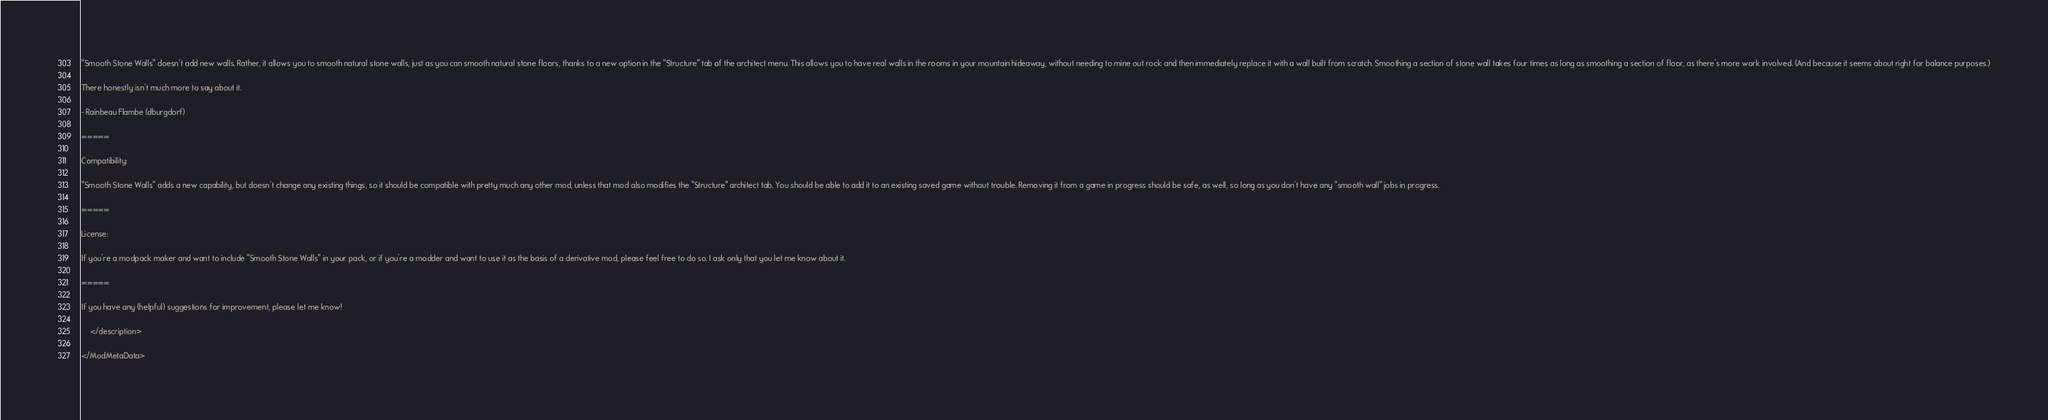Convert code to text. <code><loc_0><loc_0><loc_500><loc_500><_XML_>
"Smooth Stone Walls" doesn't add new walls. Rather, it allows you to smooth natural stone walls, just as you can smooth natural stone floors, thanks to a new option in the "Structure" tab of the architect menu. This allows you to have real walls in the rooms in your mountain hideaway, without needing to mine out rock and then immediately replace it with a wall built from scratch. Smoothing a section of stone wall takes four times as long as smoothing a section of floor, as there's more work involved. (And because it seems about right for balance purposes.)

There honestly isn't much more to say about it.

- Rainbeau Flambe (dburgdorf)

=====

Compatibility:

"Smooth Stone Walls" adds a new capability, but doesn't change any existing things, so it should be compatible with pretty much any other mod, unless that mod also modifies the "Structure" architect tab. You should be able to add it to an existing saved game without trouble. Removing it from a game in progress should be safe, as well, so long as you don't have any "smooth wall" jobs in progress.

=====

License:

If you're a modpack maker and want to include "Smooth Stone Walls" in your pack, or if you're a modder and want to use it as the basis of a derivative mod, please feel free to do so. I ask only that you let me know about it. 

=====

If you have any (helpful) suggestions for improvement, please let me know!

	</description>

</ModMetaData>
</code> 